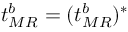<formula> <loc_0><loc_0><loc_500><loc_500>t _ { M R } ^ { b } = ( t _ { M R } ^ { b } ) ^ { * }</formula> 